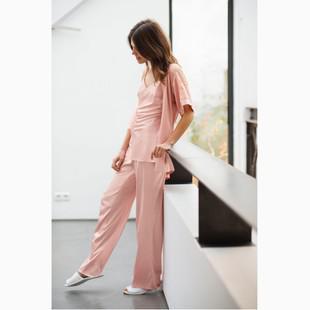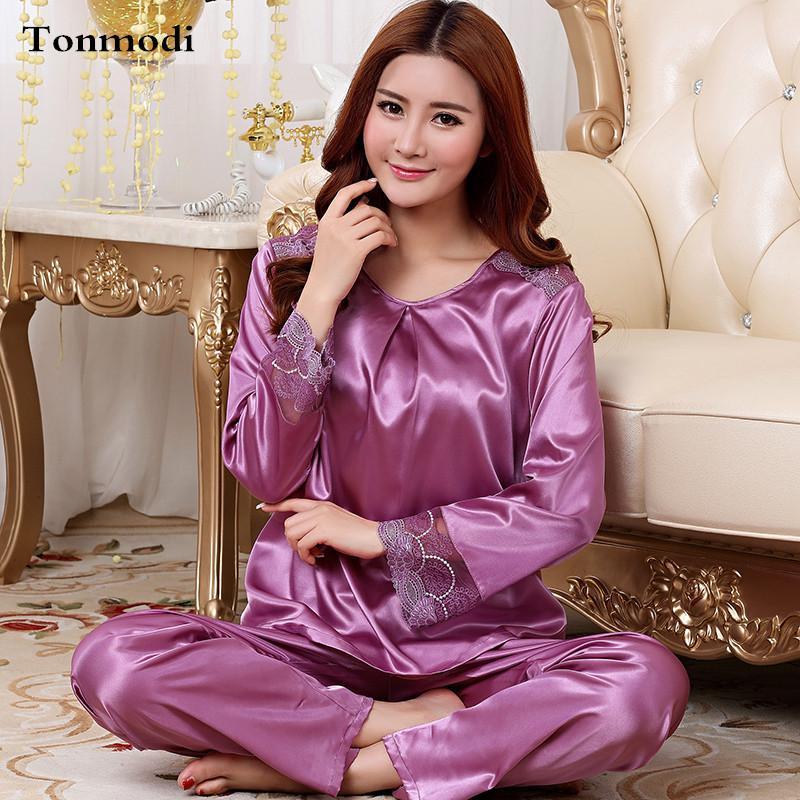The first image is the image on the left, the second image is the image on the right. Evaluate the accuracy of this statement regarding the images: "A solid colored pajama set has long pants paired with a long sleeved shirt with contrasting piping on the shirt cuffs and collar.". Is it true? Answer yes or no. No. The first image is the image on the left, the second image is the image on the right. Analyze the images presented: Is the assertion "One model is wearing purple pajamas and sitting cross-legged on the floor in front of a tufted sofa." valid? Answer yes or no. Yes. 